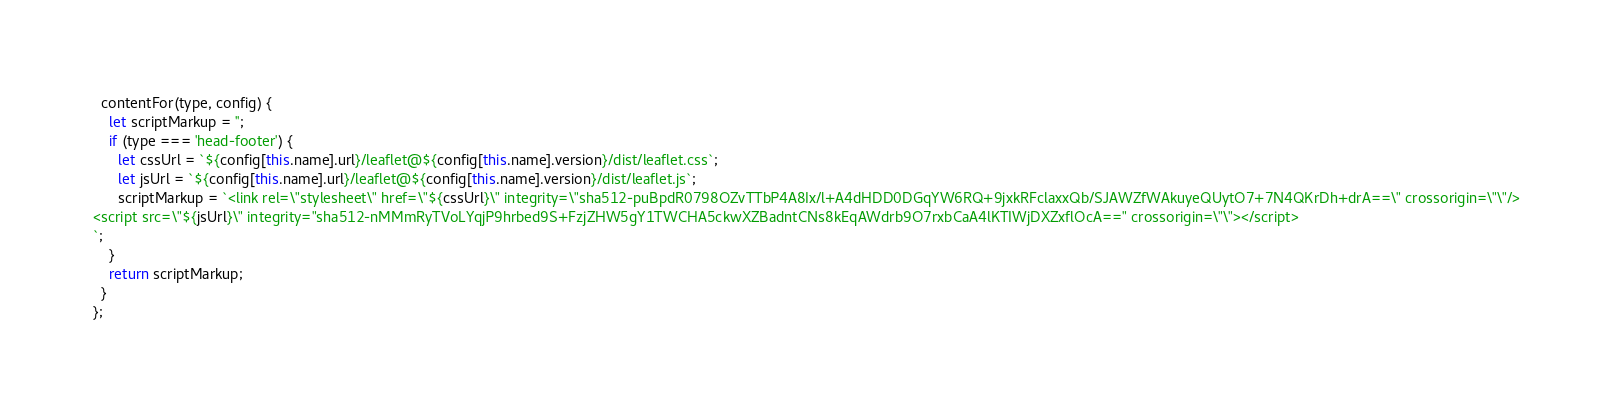<code> <loc_0><loc_0><loc_500><loc_500><_JavaScript_>  contentFor(type, config) {
    let scriptMarkup = '';
    if (type === 'head-footer') {
      let cssUrl = `${config[this.name].url}/leaflet@${config[this.name].version}/dist/leaflet.css`;
      let jsUrl = `${config[this.name].url}/leaflet@${config[this.name].version}/dist/leaflet.js`;
      scriptMarkup = `<link rel=\"stylesheet\" href=\"${cssUrl}\" integrity=\"sha512-puBpdR0798OZvTTbP4A8Ix/l+A4dHDD0DGqYW6RQ+9jxkRFclaxxQb/SJAWZfWAkuyeQUytO7+7N4QKrDh+drA==\" crossorigin=\"\"/>
<script src=\"${jsUrl}\" integrity="sha512-nMMmRyTVoLYqjP9hrbed9S+FzjZHW5gY1TWCHA5ckwXZBadntCNs8kEqAWdrb9O7rxbCaA4lKTIWjDXZxflOcA==" crossorigin=\"\"></script>
`;
    }
    return scriptMarkup;
  }
};
</code> 